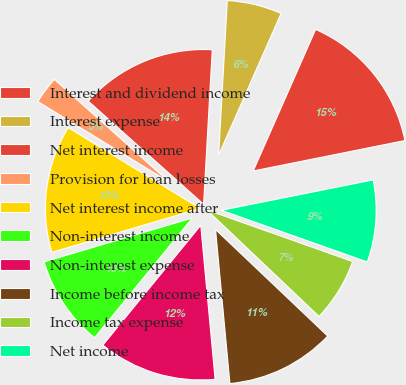Convert chart. <chart><loc_0><loc_0><loc_500><loc_500><pie_chart><fcel>Interest and dividend income<fcel>Interest expense<fcel>Net interest income<fcel>Provision for loan losses<fcel>Net interest income after<fcel>Non-interest income<fcel>Non-interest expense<fcel>Income before income tax<fcel>Income tax expense<fcel>Net income<nl><fcel>15.24%<fcel>5.72%<fcel>14.28%<fcel>2.86%<fcel>13.33%<fcel>9.52%<fcel>12.38%<fcel>11.43%<fcel>6.67%<fcel>8.57%<nl></chart> 